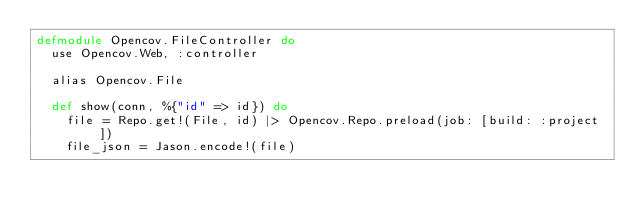Convert code to text. <code><loc_0><loc_0><loc_500><loc_500><_Elixir_>defmodule Opencov.FileController do
  use Opencov.Web, :controller

  alias Opencov.File

  def show(conn, %{"id" => id}) do
    file = Repo.get!(File, id) |> Opencov.Repo.preload(job: [build: :project])
    file_json = Jason.encode!(file)</code> 